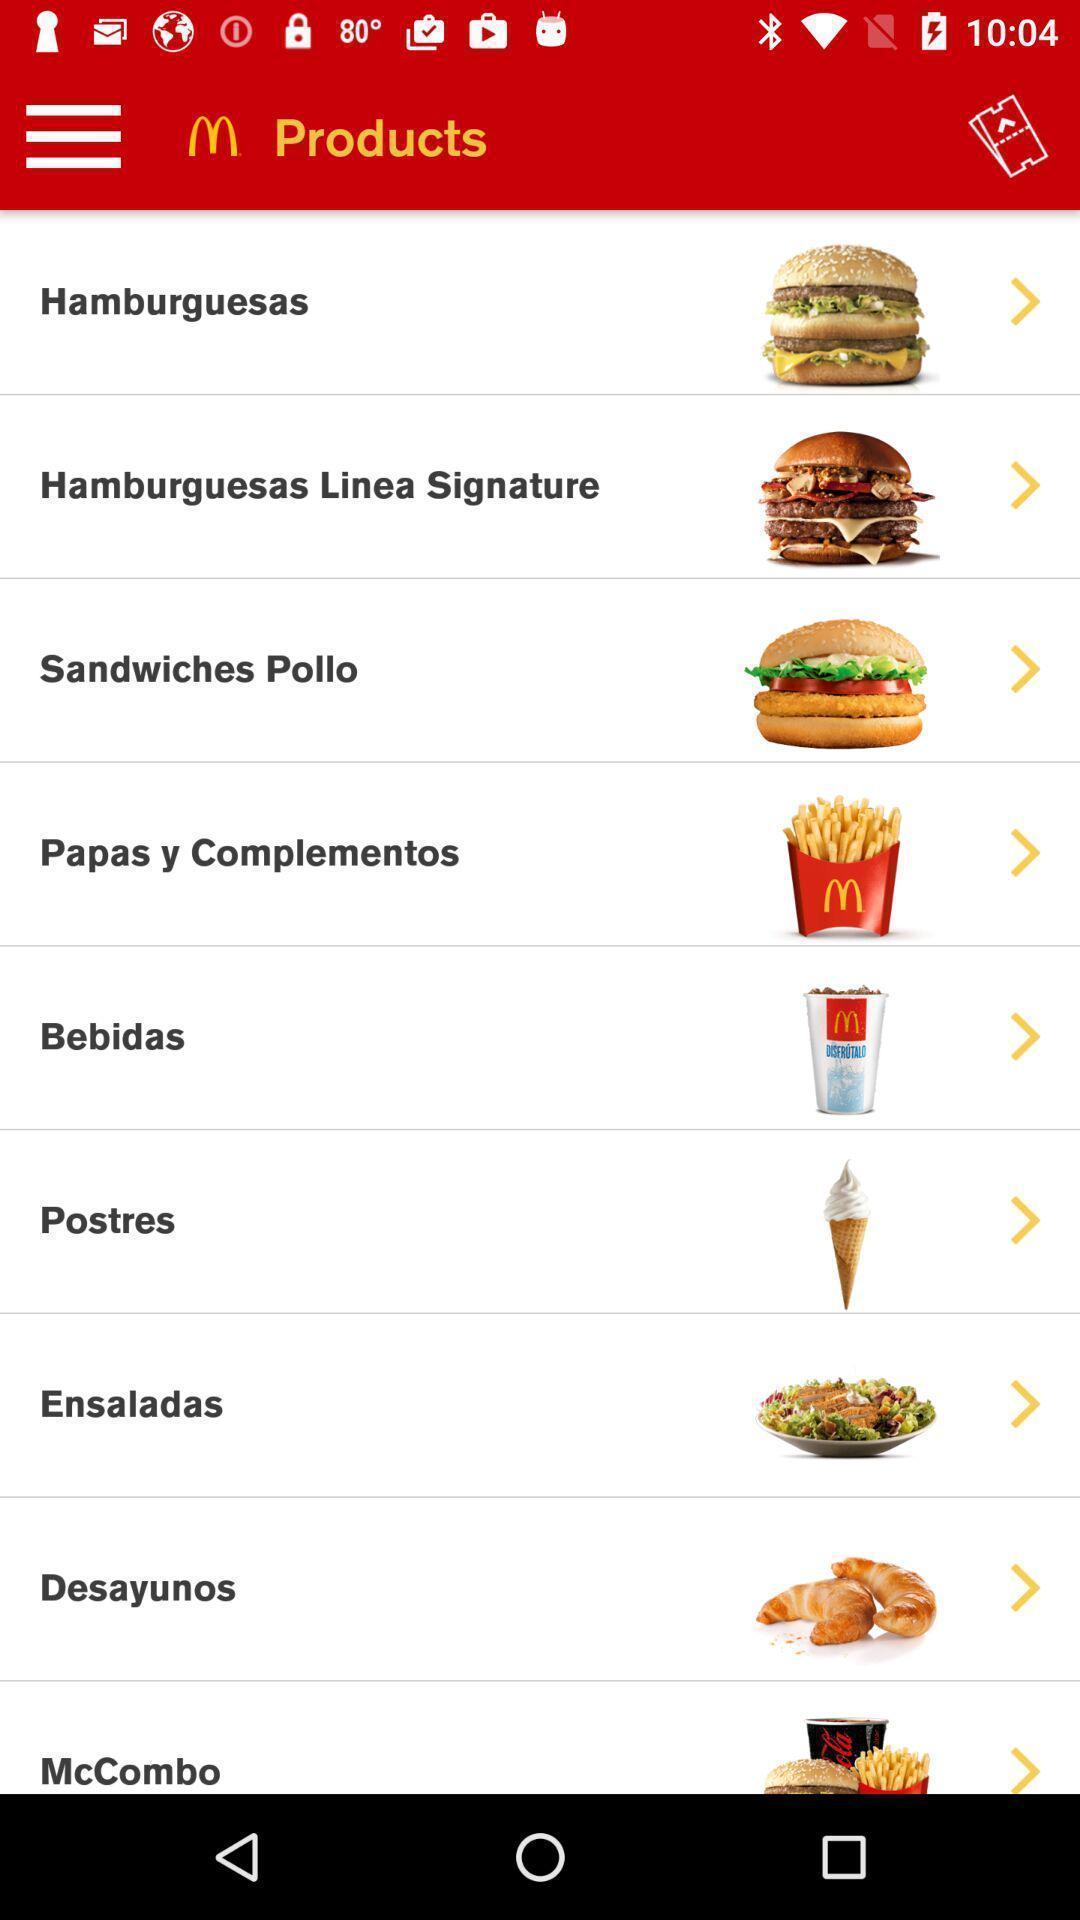What is the overall content of this screenshot? Window displaying a food app. 